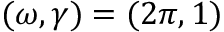<formula> <loc_0><loc_0><loc_500><loc_500>( \omega , \gamma ) = ( 2 \pi , 1 )</formula> 